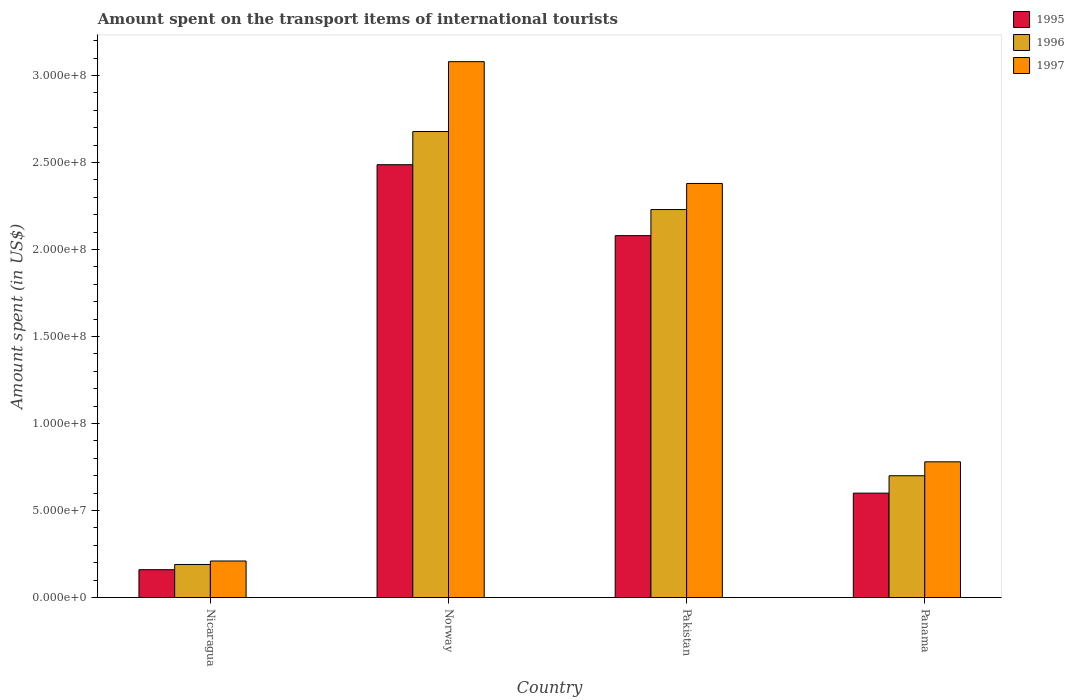How many groups of bars are there?
Provide a succinct answer. 4. Are the number of bars per tick equal to the number of legend labels?
Ensure brevity in your answer.  Yes. What is the label of the 2nd group of bars from the left?
Provide a short and direct response. Norway. What is the amount spent on the transport items of international tourists in 1995 in Panama?
Your answer should be very brief. 6.00e+07. Across all countries, what is the maximum amount spent on the transport items of international tourists in 1996?
Your answer should be compact. 2.68e+08. Across all countries, what is the minimum amount spent on the transport items of international tourists in 1996?
Keep it short and to the point. 1.90e+07. In which country was the amount spent on the transport items of international tourists in 1997 maximum?
Your answer should be very brief. Norway. In which country was the amount spent on the transport items of international tourists in 1995 minimum?
Provide a short and direct response. Nicaragua. What is the total amount spent on the transport items of international tourists in 1995 in the graph?
Offer a terse response. 5.33e+08. What is the difference between the amount spent on the transport items of international tourists in 1995 in Nicaragua and that in Norway?
Provide a short and direct response. -2.33e+08. What is the difference between the amount spent on the transport items of international tourists in 1995 in Panama and the amount spent on the transport items of international tourists in 1997 in Norway?
Keep it short and to the point. -2.48e+08. What is the average amount spent on the transport items of international tourists in 1995 per country?
Your answer should be compact. 1.33e+08. What is the difference between the amount spent on the transport items of international tourists of/in 1995 and amount spent on the transport items of international tourists of/in 1997 in Pakistan?
Your response must be concise. -3.00e+07. In how many countries, is the amount spent on the transport items of international tourists in 1996 greater than 170000000 US$?
Make the answer very short. 2. What is the ratio of the amount spent on the transport items of international tourists in 1997 in Nicaragua to that in Pakistan?
Your answer should be compact. 0.09. What is the difference between the highest and the second highest amount spent on the transport items of international tourists in 1995?
Ensure brevity in your answer.  4.08e+07. What is the difference between the highest and the lowest amount spent on the transport items of international tourists in 1995?
Your answer should be very brief. 2.33e+08. How many bars are there?
Make the answer very short. 12. Are all the bars in the graph horizontal?
Provide a short and direct response. No. How many countries are there in the graph?
Offer a terse response. 4. What is the difference between two consecutive major ticks on the Y-axis?
Offer a terse response. 5.00e+07. Does the graph contain grids?
Give a very brief answer. No. Where does the legend appear in the graph?
Your answer should be very brief. Top right. What is the title of the graph?
Provide a short and direct response. Amount spent on the transport items of international tourists. What is the label or title of the X-axis?
Offer a very short reply. Country. What is the label or title of the Y-axis?
Your answer should be very brief. Amount spent (in US$). What is the Amount spent (in US$) of 1995 in Nicaragua?
Ensure brevity in your answer.  1.60e+07. What is the Amount spent (in US$) of 1996 in Nicaragua?
Offer a very short reply. 1.90e+07. What is the Amount spent (in US$) of 1997 in Nicaragua?
Keep it short and to the point. 2.10e+07. What is the Amount spent (in US$) of 1995 in Norway?
Provide a short and direct response. 2.49e+08. What is the Amount spent (in US$) in 1996 in Norway?
Give a very brief answer. 2.68e+08. What is the Amount spent (in US$) in 1997 in Norway?
Your response must be concise. 3.08e+08. What is the Amount spent (in US$) in 1995 in Pakistan?
Keep it short and to the point. 2.08e+08. What is the Amount spent (in US$) of 1996 in Pakistan?
Provide a succinct answer. 2.23e+08. What is the Amount spent (in US$) in 1997 in Pakistan?
Offer a terse response. 2.38e+08. What is the Amount spent (in US$) of 1995 in Panama?
Offer a terse response. 6.00e+07. What is the Amount spent (in US$) of 1996 in Panama?
Your answer should be very brief. 7.00e+07. What is the Amount spent (in US$) in 1997 in Panama?
Ensure brevity in your answer.  7.80e+07. Across all countries, what is the maximum Amount spent (in US$) of 1995?
Your answer should be compact. 2.49e+08. Across all countries, what is the maximum Amount spent (in US$) of 1996?
Your response must be concise. 2.68e+08. Across all countries, what is the maximum Amount spent (in US$) in 1997?
Keep it short and to the point. 3.08e+08. Across all countries, what is the minimum Amount spent (in US$) in 1995?
Give a very brief answer. 1.60e+07. Across all countries, what is the minimum Amount spent (in US$) of 1996?
Offer a terse response. 1.90e+07. Across all countries, what is the minimum Amount spent (in US$) in 1997?
Offer a very short reply. 2.10e+07. What is the total Amount spent (in US$) in 1995 in the graph?
Your response must be concise. 5.33e+08. What is the total Amount spent (in US$) of 1996 in the graph?
Your response must be concise. 5.80e+08. What is the total Amount spent (in US$) in 1997 in the graph?
Offer a very short reply. 6.45e+08. What is the difference between the Amount spent (in US$) in 1995 in Nicaragua and that in Norway?
Make the answer very short. -2.33e+08. What is the difference between the Amount spent (in US$) of 1996 in Nicaragua and that in Norway?
Your answer should be very brief. -2.49e+08. What is the difference between the Amount spent (in US$) of 1997 in Nicaragua and that in Norway?
Your answer should be compact. -2.87e+08. What is the difference between the Amount spent (in US$) of 1995 in Nicaragua and that in Pakistan?
Your answer should be compact. -1.92e+08. What is the difference between the Amount spent (in US$) of 1996 in Nicaragua and that in Pakistan?
Your response must be concise. -2.04e+08. What is the difference between the Amount spent (in US$) of 1997 in Nicaragua and that in Pakistan?
Your response must be concise. -2.17e+08. What is the difference between the Amount spent (in US$) in 1995 in Nicaragua and that in Panama?
Offer a very short reply. -4.40e+07. What is the difference between the Amount spent (in US$) of 1996 in Nicaragua and that in Panama?
Offer a terse response. -5.10e+07. What is the difference between the Amount spent (in US$) of 1997 in Nicaragua and that in Panama?
Your answer should be very brief. -5.70e+07. What is the difference between the Amount spent (in US$) in 1995 in Norway and that in Pakistan?
Provide a short and direct response. 4.08e+07. What is the difference between the Amount spent (in US$) of 1996 in Norway and that in Pakistan?
Your response must be concise. 4.48e+07. What is the difference between the Amount spent (in US$) of 1997 in Norway and that in Pakistan?
Your answer should be very brief. 7.00e+07. What is the difference between the Amount spent (in US$) in 1995 in Norway and that in Panama?
Your answer should be very brief. 1.89e+08. What is the difference between the Amount spent (in US$) of 1996 in Norway and that in Panama?
Provide a short and direct response. 1.98e+08. What is the difference between the Amount spent (in US$) of 1997 in Norway and that in Panama?
Provide a short and direct response. 2.30e+08. What is the difference between the Amount spent (in US$) of 1995 in Pakistan and that in Panama?
Offer a very short reply. 1.48e+08. What is the difference between the Amount spent (in US$) of 1996 in Pakistan and that in Panama?
Your answer should be compact. 1.53e+08. What is the difference between the Amount spent (in US$) in 1997 in Pakistan and that in Panama?
Offer a very short reply. 1.60e+08. What is the difference between the Amount spent (in US$) in 1995 in Nicaragua and the Amount spent (in US$) in 1996 in Norway?
Make the answer very short. -2.52e+08. What is the difference between the Amount spent (in US$) in 1995 in Nicaragua and the Amount spent (in US$) in 1997 in Norway?
Offer a very short reply. -2.92e+08. What is the difference between the Amount spent (in US$) of 1996 in Nicaragua and the Amount spent (in US$) of 1997 in Norway?
Your answer should be compact. -2.89e+08. What is the difference between the Amount spent (in US$) of 1995 in Nicaragua and the Amount spent (in US$) of 1996 in Pakistan?
Keep it short and to the point. -2.07e+08. What is the difference between the Amount spent (in US$) of 1995 in Nicaragua and the Amount spent (in US$) of 1997 in Pakistan?
Provide a short and direct response. -2.22e+08. What is the difference between the Amount spent (in US$) in 1996 in Nicaragua and the Amount spent (in US$) in 1997 in Pakistan?
Offer a very short reply. -2.19e+08. What is the difference between the Amount spent (in US$) of 1995 in Nicaragua and the Amount spent (in US$) of 1996 in Panama?
Make the answer very short. -5.40e+07. What is the difference between the Amount spent (in US$) in 1995 in Nicaragua and the Amount spent (in US$) in 1997 in Panama?
Provide a short and direct response. -6.20e+07. What is the difference between the Amount spent (in US$) in 1996 in Nicaragua and the Amount spent (in US$) in 1997 in Panama?
Keep it short and to the point. -5.90e+07. What is the difference between the Amount spent (in US$) in 1995 in Norway and the Amount spent (in US$) in 1996 in Pakistan?
Keep it short and to the point. 2.58e+07. What is the difference between the Amount spent (in US$) of 1995 in Norway and the Amount spent (in US$) of 1997 in Pakistan?
Offer a very short reply. 1.08e+07. What is the difference between the Amount spent (in US$) of 1996 in Norway and the Amount spent (in US$) of 1997 in Pakistan?
Keep it short and to the point. 2.98e+07. What is the difference between the Amount spent (in US$) of 1995 in Norway and the Amount spent (in US$) of 1996 in Panama?
Keep it short and to the point. 1.79e+08. What is the difference between the Amount spent (in US$) in 1995 in Norway and the Amount spent (in US$) in 1997 in Panama?
Provide a short and direct response. 1.71e+08. What is the difference between the Amount spent (in US$) in 1996 in Norway and the Amount spent (in US$) in 1997 in Panama?
Your answer should be compact. 1.90e+08. What is the difference between the Amount spent (in US$) in 1995 in Pakistan and the Amount spent (in US$) in 1996 in Panama?
Keep it short and to the point. 1.38e+08. What is the difference between the Amount spent (in US$) in 1995 in Pakistan and the Amount spent (in US$) in 1997 in Panama?
Offer a terse response. 1.30e+08. What is the difference between the Amount spent (in US$) of 1996 in Pakistan and the Amount spent (in US$) of 1997 in Panama?
Your answer should be compact. 1.45e+08. What is the average Amount spent (in US$) in 1995 per country?
Your answer should be compact. 1.33e+08. What is the average Amount spent (in US$) in 1996 per country?
Give a very brief answer. 1.45e+08. What is the average Amount spent (in US$) in 1997 per country?
Provide a succinct answer. 1.61e+08. What is the difference between the Amount spent (in US$) of 1995 and Amount spent (in US$) of 1996 in Nicaragua?
Provide a succinct answer. -3.00e+06. What is the difference between the Amount spent (in US$) of 1995 and Amount spent (in US$) of 1997 in Nicaragua?
Ensure brevity in your answer.  -5.00e+06. What is the difference between the Amount spent (in US$) in 1996 and Amount spent (in US$) in 1997 in Nicaragua?
Provide a short and direct response. -2.00e+06. What is the difference between the Amount spent (in US$) in 1995 and Amount spent (in US$) in 1996 in Norway?
Provide a succinct answer. -1.91e+07. What is the difference between the Amount spent (in US$) in 1995 and Amount spent (in US$) in 1997 in Norway?
Ensure brevity in your answer.  -5.92e+07. What is the difference between the Amount spent (in US$) in 1996 and Amount spent (in US$) in 1997 in Norway?
Give a very brief answer. -4.02e+07. What is the difference between the Amount spent (in US$) of 1995 and Amount spent (in US$) of 1996 in Pakistan?
Provide a succinct answer. -1.50e+07. What is the difference between the Amount spent (in US$) in 1995 and Amount spent (in US$) in 1997 in Pakistan?
Offer a very short reply. -3.00e+07. What is the difference between the Amount spent (in US$) of 1996 and Amount spent (in US$) of 1997 in Pakistan?
Provide a short and direct response. -1.50e+07. What is the difference between the Amount spent (in US$) in 1995 and Amount spent (in US$) in 1996 in Panama?
Provide a short and direct response. -1.00e+07. What is the difference between the Amount spent (in US$) of 1995 and Amount spent (in US$) of 1997 in Panama?
Provide a short and direct response. -1.80e+07. What is the difference between the Amount spent (in US$) in 1996 and Amount spent (in US$) in 1997 in Panama?
Your answer should be compact. -8.00e+06. What is the ratio of the Amount spent (in US$) of 1995 in Nicaragua to that in Norway?
Give a very brief answer. 0.06. What is the ratio of the Amount spent (in US$) in 1996 in Nicaragua to that in Norway?
Provide a short and direct response. 0.07. What is the ratio of the Amount spent (in US$) in 1997 in Nicaragua to that in Norway?
Give a very brief answer. 0.07. What is the ratio of the Amount spent (in US$) in 1995 in Nicaragua to that in Pakistan?
Ensure brevity in your answer.  0.08. What is the ratio of the Amount spent (in US$) in 1996 in Nicaragua to that in Pakistan?
Your answer should be very brief. 0.09. What is the ratio of the Amount spent (in US$) in 1997 in Nicaragua to that in Pakistan?
Ensure brevity in your answer.  0.09. What is the ratio of the Amount spent (in US$) in 1995 in Nicaragua to that in Panama?
Your response must be concise. 0.27. What is the ratio of the Amount spent (in US$) in 1996 in Nicaragua to that in Panama?
Make the answer very short. 0.27. What is the ratio of the Amount spent (in US$) in 1997 in Nicaragua to that in Panama?
Your response must be concise. 0.27. What is the ratio of the Amount spent (in US$) of 1995 in Norway to that in Pakistan?
Provide a succinct answer. 1.2. What is the ratio of the Amount spent (in US$) of 1996 in Norway to that in Pakistan?
Ensure brevity in your answer.  1.2. What is the ratio of the Amount spent (in US$) in 1997 in Norway to that in Pakistan?
Provide a succinct answer. 1.29. What is the ratio of the Amount spent (in US$) in 1995 in Norway to that in Panama?
Ensure brevity in your answer.  4.15. What is the ratio of the Amount spent (in US$) of 1996 in Norway to that in Panama?
Offer a very short reply. 3.83. What is the ratio of the Amount spent (in US$) of 1997 in Norway to that in Panama?
Keep it short and to the point. 3.95. What is the ratio of the Amount spent (in US$) in 1995 in Pakistan to that in Panama?
Make the answer very short. 3.47. What is the ratio of the Amount spent (in US$) of 1996 in Pakistan to that in Panama?
Provide a succinct answer. 3.19. What is the ratio of the Amount spent (in US$) in 1997 in Pakistan to that in Panama?
Make the answer very short. 3.05. What is the difference between the highest and the second highest Amount spent (in US$) in 1995?
Offer a terse response. 4.08e+07. What is the difference between the highest and the second highest Amount spent (in US$) of 1996?
Your answer should be very brief. 4.48e+07. What is the difference between the highest and the second highest Amount spent (in US$) in 1997?
Offer a terse response. 7.00e+07. What is the difference between the highest and the lowest Amount spent (in US$) of 1995?
Make the answer very short. 2.33e+08. What is the difference between the highest and the lowest Amount spent (in US$) of 1996?
Your response must be concise. 2.49e+08. What is the difference between the highest and the lowest Amount spent (in US$) in 1997?
Your answer should be very brief. 2.87e+08. 